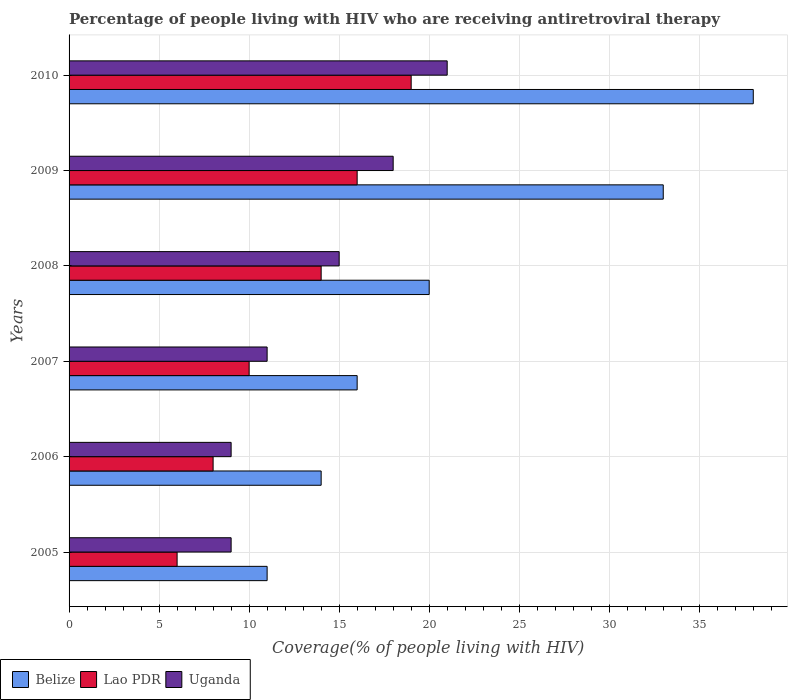How many different coloured bars are there?
Ensure brevity in your answer.  3. How many groups of bars are there?
Keep it short and to the point. 6. Are the number of bars per tick equal to the number of legend labels?
Give a very brief answer. Yes. How many bars are there on the 4th tick from the top?
Ensure brevity in your answer.  3. What is the label of the 5th group of bars from the top?
Make the answer very short. 2006. What is the percentage of the HIV infected people who are receiving antiretroviral therapy in Lao PDR in 2008?
Provide a succinct answer. 14. Across all years, what is the maximum percentage of the HIV infected people who are receiving antiretroviral therapy in Belize?
Provide a short and direct response. 38. In which year was the percentage of the HIV infected people who are receiving antiretroviral therapy in Belize minimum?
Give a very brief answer. 2005. What is the total percentage of the HIV infected people who are receiving antiretroviral therapy in Belize in the graph?
Give a very brief answer. 132. What is the difference between the percentage of the HIV infected people who are receiving antiretroviral therapy in Belize in 2007 and that in 2009?
Provide a succinct answer. -17. What is the difference between the percentage of the HIV infected people who are receiving antiretroviral therapy in Belize in 2010 and the percentage of the HIV infected people who are receiving antiretroviral therapy in Uganda in 2009?
Offer a very short reply. 20. What is the average percentage of the HIV infected people who are receiving antiretroviral therapy in Lao PDR per year?
Keep it short and to the point. 12.17. In the year 2010, what is the difference between the percentage of the HIV infected people who are receiving antiretroviral therapy in Lao PDR and percentage of the HIV infected people who are receiving antiretroviral therapy in Uganda?
Your answer should be very brief. -2. What is the ratio of the percentage of the HIV infected people who are receiving antiretroviral therapy in Lao PDR in 2008 to that in 2010?
Provide a short and direct response. 0.74. Is the percentage of the HIV infected people who are receiving antiretroviral therapy in Lao PDR in 2006 less than that in 2008?
Your answer should be compact. Yes. What is the difference between the highest and the lowest percentage of the HIV infected people who are receiving antiretroviral therapy in Lao PDR?
Your answer should be compact. 13. What does the 1st bar from the top in 2009 represents?
Make the answer very short. Uganda. What does the 3rd bar from the bottom in 2006 represents?
Give a very brief answer. Uganda. Is it the case that in every year, the sum of the percentage of the HIV infected people who are receiving antiretroviral therapy in Uganda and percentage of the HIV infected people who are receiving antiretroviral therapy in Belize is greater than the percentage of the HIV infected people who are receiving antiretroviral therapy in Lao PDR?
Your response must be concise. Yes. How many bars are there?
Your answer should be compact. 18. Are the values on the major ticks of X-axis written in scientific E-notation?
Your answer should be very brief. No. How are the legend labels stacked?
Provide a short and direct response. Horizontal. What is the title of the graph?
Offer a terse response. Percentage of people living with HIV who are receiving antiretroviral therapy. What is the label or title of the X-axis?
Give a very brief answer. Coverage(% of people living with HIV). What is the label or title of the Y-axis?
Give a very brief answer. Years. What is the Coverage(% of people living with HIV) in Belize in 2006?
Your response must be concise. 14. What is the Coverage(% of people living with HIV) of Uganda in 2006?
Give a very brief answer. 9. What is the Coverage(% of people living with HIV) of Belize in 2007?
Keep it short and to the point. 16. What is the Coverage(% of people living with HIV) of Uganda in 2007?
Make the answer very short. 11. What is the Coverage(% of people living with HIV) in Belize in 2008?
Offer a very short reply. 20. What is the Coverage(% of people living with HIV) in Lao PDR in 2008?
Offer a very short reply. 14. What is the Coverage(% of people living with HIV) in Lao PDR in 2009?
Ensure brevity in your answer.  16. What is the Coverage(% of people living with HIV) of Belize in 2010?
Your answer should be very brief. 38. What is the Coverage(% of people living with HIV) of Lao PDR in 2010?
Keep it short and to the point. 19. What is the total Coverage(% of people living with HIV) of Belize in the graph?
Give a very brief answer. 132. What is the total Coverage(% of people living with HIV) in Lao PDR in the graph?
Make the answer very short. 73. What is the difference between the Coverage(% of people living with HIV) of Lao PDR in 2005 and that in 2006?
Offer a very short reply. -2. What is the difference between the Coverage(% of people living with HIV) in Uganda in 2005 and that in 2007?
Your answer should be compact. -2. What is the difference between the Coverage(% of people living with HIV) in Belize in 2005 and that in 2008?
Your response must be concise. -9. What is the difference between the Coverage(% of people living with HIV) in Uganda in 2005 and that in 2008?
Keep it short and to the point. -6. What is the difference between the Coverage(% of people living with HIV) in Belize in 2005 and that in 2009?
Your response must be concise. -22. What is the difference between the Coverage(% of people living with HIV) of Uganda in 2005 and that in 2009?
Provide a succinct answer. -9. What is the difference between the Coverage(% of people living with HIV) in Lao PDR in 2005 and that in 2010?
Your answer should be compact. -13. What is the difference between the Coverage(% of people living with HIV) in Belize in 2006 and that in 2007?
Keep it short and to the point. -2. What is the difference between the Coverage(% of people living with HIV) in Belize in 2006 and that in 2008?
Make the answer very short. -6. What is the difference between the Coverage(% of people living with HIV) in Lao PDR in 2006 and that in 2008?
Make the answer very short. -6. What is the difference between the Coverage(% of people living with HIV) in Uganda in 2006 and that in 2008?
Keep it short and to the point. -6. What is the difference between the Coverage(% of people living with HIV) in Belize in 2006 and that in 2009?
Keep it short and to the point. -19. What is the difference between the Coverage(% of people living with HIV) of Lao PDR in 2006 and that in 2009?
Ensure brevity in your answer.  -8. What is the difference between the Coverage(% of people living with HIV) of Lao PDR in 2006 and that in 2010?
Offer a very short reply. -11. What is the difference between the Coverage(% of people living with HIV) of Lao PDR in 2007 and that in 2008?
Ensure brevity in your answer.  -4. What is the difference between the Coverage(% of people living with HIV) of Lao PDR in 2007 and that in 2010?
Ensure brevity in your answer.  -9. What is the difference between the Coverage(% of people living with HIV) of Uganda in 2007 and that in 2010?
Provide a succinct answer. -10. What is the difference between the Coverage(% of people living with HIV) in Uganda in 2008 and that in 2009?
Your answer should be very brief. -3. What is the difference between the Coverage(% of people living with HIV) of Belize in 2008 and that in 2010?
Ensure brevity in your answer.  -18. What is the difference between the Coverage(% of people living with HIV) of Belize in 2009 and that in 2010?
Provide a succinct answer. -5. What is the difference between the Coverage(% of people living with HIV) in Lao PDR in 2009 and that in 2010?
Keep it short and to the point. -3. What is the difference between the Coverage(% of people living with HIV) of Lao PDR in 2005 and the Coverage(% of people living with HIV) of Uganda in 2006?
Your answer should be compact. -3. What is the difference between the Coverage(% of people living with HIV) of Belize in 2005 and the Coverage(% of people living with HIV) of Uganda in 2007?
Provide a succinct answer. 0. What is the difference between the Coverage(% of people living with HIV) in Lao PDR in 2005 and the Coverage(% of people living with HIV) in Uganda in 2007?
Offer a very short reply. -5. What is the difference between the Coverage(% of people living with HIV) in Belize in 2005 and the Coverage(% of people living with HIV) in Lao PDR in 2008?
Offer a very short reply. -3. What is the difference between the Coverage(% of people living with HIV) of Belize in 2005 and the Coverage(% of people living with HIV) of Lao PDR in 2009?
Ensure brevity in your answer.  -5. What is the difference between the Coverage(% of people living with HIV) in Lao PDR in 2005 and the Coverage(% of people living with HIV) in Uganda in 2009?
Offer a terse response. -12. What is the difference between the Coverage(% of people living with HIV) of Belize in 2005 and the Coverage(% of people living with HIV) of Uganda in 2010?
Keep it short and to the point. -10. What is the difference between the Coverage(% of people living with HIV) of Belize in 2006 and the Coverage(% of people living with HIV) of Lao PDR in 2007?
Keep it short and to the point. 4. What is the difference between the Coverage(% of people living with HIV) of Belize in 2006 and the Coverage(% of people living with HIV) of Uganda in 2007?
Keep it short and to the point. 3. What is the difference between the Coverage(% of people living with HIV) of Belize in 2006 and the Coverage(% of people living with HIV) of Lao PDR in 2008?
Give a very brief answer. 0. What is the difference between the Coverage(% of people living with HIV) of Belize in 2006 and the Coverage(% of people living with HIV) of Uganda in 2008?
Provide a succinct answer. -1. What is the difference between the Coverage(% of people living with HIV) of Belize in 2006 and the Coverage(% of people living with HIV) of Lao PDR in 2009?
Your answer should be very brief. -2. What is the difference between the Coverage(% of people living with HIV) in Lao PDR in 2006 and the Coverage(% of people living with HIV) in Uganda in 2010?
Provide a short and direct response. -13. What is the difference between the Coverage(% of people living with HIV) of Belize in 2007 and the Coverage(% of people living with HIV) of Lao PDR in 2008?
Keep it short and to the point. 2. What is the difference between the Coverage(% of people living with HIV) of Lao PDR in 2007 and the Coverage(% of people living with HIV) of Uganda in 2008?
Keep it short and to the point. -5. What is the difference between the Coverage(% of people living with HIV) in Belize in 2007 and the Coverage(% of people living with HIV) in Lao PDR in 2010?
Give a very brief answer. -3. What is the difference between the Coverage(% of people living with HIV) of Belize in 2007 and the Coverage(% of people living with HIV) of Uganda in 2010?
Your response must be concise. -5. What is the difference between the Coverage(% of people living with HIV) of Belize in 2008 and the Coverage(% of people living with HIV) of Uganda in 2009?
Offer a very short reply. 2. What is the difference between the Coverage(% of people living with HIV) of Lao PDR in 2008 and the Coverage(% of people living with HIV) of Uganda in 2009?
Offer a very short reply. -4. What is the difference between the Coverage(% of people living with HIV) of Belize in 2009 and the Coverage(% of people living with HIV) of Lao PDR in 2010?
Keep it short and to the point. 14. What is the difference between the Coverage(% of people living with HIV) of Belize in 2009 and the Coverage(% of people living with HIV) of Uganda in 2010?
Give a very brief answer. 12. What is the difference between the Coverage(% of people living with HIV) of Lao PDR in 2009 and the Coverage(% of people living with HIV) of Uganda in 2010?
Give a very brief answer. -5. What is the average Coverage(% of people living with HIV) in Belize per year?
Make the answer very short. 22. What is the average Coverage(% of people living with HIV) of Lao PDR per year?
Your answer should be compact. 12.17. What is the average Coverage(% of people living with HIV) of Uganda per year?
Ensure brevity in your answer.  13.83. In the year 2005, what is the difference between the Coverage(% of people living with HIV) in Belize and Coverage(% of people living with HIV) in Uganda?
Your response must be concise. 2. In the year 2006, what is the difference between the Coverage(% of people living with HIV) of Belize and Coverage(% of people living with HIV) of Lao PDR?
Make the answer very short. 6. In the year 2007, what is the difference between the Coverage(% of people living with HIV) in Lao PDR and Coverage(% of people living with HIV) in Uganda?
Your response must be concise. -1. In the year 2008, what is the difference between the Coverage(% of people living with HIV) of Belize and Coverage(% of people living with HIV) of Uganda?
Offer a terse response. 5. In the year 2008, what is the difference between the Coverage(% of people living with HIV) in Lao PDR and Coverage(% of people living with HIV) in Uganda?
Your answer should be very brief. -1. In the year 2009, what is the difference between the Coverage(% of people living with HIV) of Belize and Coverage(% of people living with HIV) of Lao PDR?
Provide a short and direct response. 17. In the year 2009, what is the difference between the Coverage(% of people living with HIV) in Lao PDR and Coverage(% of people living with HIV) in Uganda?
Make the answer very short. -2. In the year 2010, what is the difference between the Coverage(% of people living with HIV) in Lao PDR and Coverage(% of people living with HIV) in Uganda?
Offer a terse response. -2. What is the ratio of the Coverage(% of people living with HIV) of Belize in 2005 to that in 2006?
Your answer should be compact. 0.79. What is the ratio of the Coverage(% of people living with HIV) in Uganda in 2005 to that in 2006?
Give a very brief answer. 1. What is the ratio of the Coverage(% of people living with HIV) in Belize in 2005 to that in 2007?
Keep it short and to the point. 0.69. What is the ratio of the Coverage(% of people living with HIV) of Uganda in 2005 to that in 2007?
Make the answer very short. 0.82. What is the ratio of the Coverage(% of people living with HIV) of Belize in 2005 to that in 2008?
Your answer should be compact. 0.55. What is the ratio of the Coverage(% of people living with HIV) of Lao PDR in 2005 to that in 2008?
Ensure brevity in your answer.  0.43. What is the ratio of the Coverage(% of people living with HIV) in Uganda in 2005 to that in 2008?
Provide a short and direct response. 0.6. What is the ratio of the Coverage(% of people living with HIV) of Belize in 2005 to that in 2010?
Your response must be concise. 0.29. What is the ratio of the Coverage(% of people living with HIV) in Lao PDR in 2005 to that in 2010?
Your response must be concise. 0.32. What is the ratio of the Coverage(% of people living with HIV) of Uganda in 2005 to that in 2010?
Provide a succinct answer. 0.43. What is the ratio of the Coverage(% of people living with HIV) of Uganda in 2006 to that in 2007?
Your response must be concise. 0.82. What is the ratio of the Coverage(% of people living with HIV) in Belize in 2006 to that in 2008?
Offer a very short reply. 0.7. What is the ratio of the Coverage(% of people living with HIV) in Lao PDR in 2006 to that in 2008?
Offer a very short reply. 0.57. What is the ratio of the Coverage(% of people living with HIV) of Belize in 2006 to that in 2009?
Your response must be concise. 0.42. What is the ratio of the Coverage(% of people living with HIV) of Lao PDR in 2006 to that in 2009?
Provide a short and direct response. 0.5. What is the ratio of the Coverage(% of people living with HIV) in Uganda in 2006 to that in 2009?
Offer a very short reply. 0.5. What is the ratio of the Coverage(% of people living with HIV) of Belize in 2006 to that in 2010?
Provide a succinct answer. 0.37. What is the ratio of the Coverage(% of people living with HIV) of Lao PDR in 2006 to that in 2010?
Give a very brief answer. 0.42. What is the ratio of the Coverage(% of people living with HIV) of Uganda in 2006 to that in 2010?
Give a very brief answer. 0.43. What is the ratio of the Coverage(% of people living with HIV) in Uganda in 2007 to that in 2008?
Your answer should be very brief. 0.73. What is the ratio of the Coverage(% of people living with HIV) in Belize in 2007 to that in 2009?
Your response must be concise. 0.48. What is the ratio of the Coverage(% of people living with HIV) of Uganda in 2007 to that in 2009?
Give a very brief answer. 0.61. What is the ratio of the Coverage(% of people living with HIV) of Belize in 2007 to that in 2010?
Offer a terse response. 0.42. What is the ratio of the Coverage(% of people living with HIV) of Lao PDR in 2007 to that in 2010?
Offer a terse response. 0.53. What is the ratio of the Coverage(% of people living with HIV) of Uganda in 2007 to that in 2010?
Provide a short and direct response. 0.52. What is the ratio of the Coverage(% of people living with HIV) in Belize in 2008 to that in 2009?
Provide a succinct answer. 0.61. What is the ratio of the Coverage(% of people living with HIV) in Belize in 2008 to that in 2010?
Your response must be concise. 0.53. What is the ratio of the Coverage(% of people living with HIV) of Lao PDR in 2008 to that in 2010?
Make the answer very short. 0.74. What is the ratio of the Coverage(% of people living with HIV) in Uganda in 2008 to that in 2010?
Provide a short and direct response. 0.71. What is the ratio of the Coverage(% of people living with HIV) in Belize in 2009 to that in 2010?
Make the answer very short. 0.87. What is the ratio of the Coverage(% of people living with HIV) in Lao PDR in 2009 to that in 2010?
Your answer should be compact. 0.84. What is the ratio of the Coverage(% of people living with HIV) in Uganda in 2009 to that in 2010?
Provide a succinct answer. 0.86. What is the difference between the highest and the second highest Coverage(% of people living with HIV) in Belize?
Give a very brief answer. 5. 